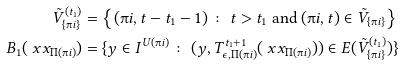Convert formula to latex. <formula><loc_0><loc_0><loc_500><loc_500>\tilde { V } ^ { ( t _ { 1 } ) } _ { \{ \i i \} } & = \left \{ ( \i i , t - t _ { 1 } - 1 ) \, \colon \, t > t _ { 1 } \text { and } ( \i i , t ) \in \tilde { V } _ { \{ \i i \} } \right \} \\ B _ { 1 } ( \ x x _ { \Pi ( \i i ) } ) & = \{ y \in I ^ { U ( \i i ) } \, \colon \, ( y , T _ { \epsilon , \Pi ( \i i ) } ^ { t _ { 1 } + 1 } ( \ x x _ { \Pi ( \i i ) } ) ) \in E ( \tilde { V } ^ { ( t _ { 1 } ) } _ { \{ \i i \} } ) \}</formula> 